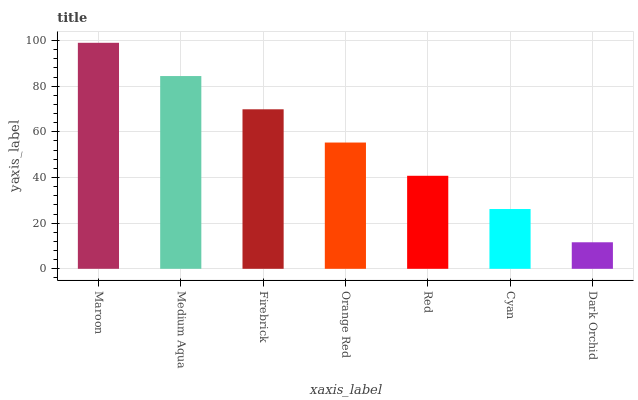Is Dark Orchid the minimum?
Answer yes or no. Yes. Is Maroon the maximum?
Answer yes or no. Yes. Is Medium Aqua the minimum?
Answer yes or no. No. Is Medium Aqua the maximum?
Answer yes or no. No. Is Maroon greater than Medium Aqua?
Answer yes or no. Yes. Is Medium Aqua less than Maroon?
Answer yes or no. Yes. Is Medium Aqua greater than Maroon?
Answer yes or no. No. Is Maroon less than Medium Aqua?
Answer yes or no. No. Is Orange Red the high median?
Answer yes or no. Yes. Is Orange Red the low median?
Answer yes or no. Yes. Is Maroon the high median?
Answer yes or no. No. Is Red the low median?
Answer yes or no. No. 